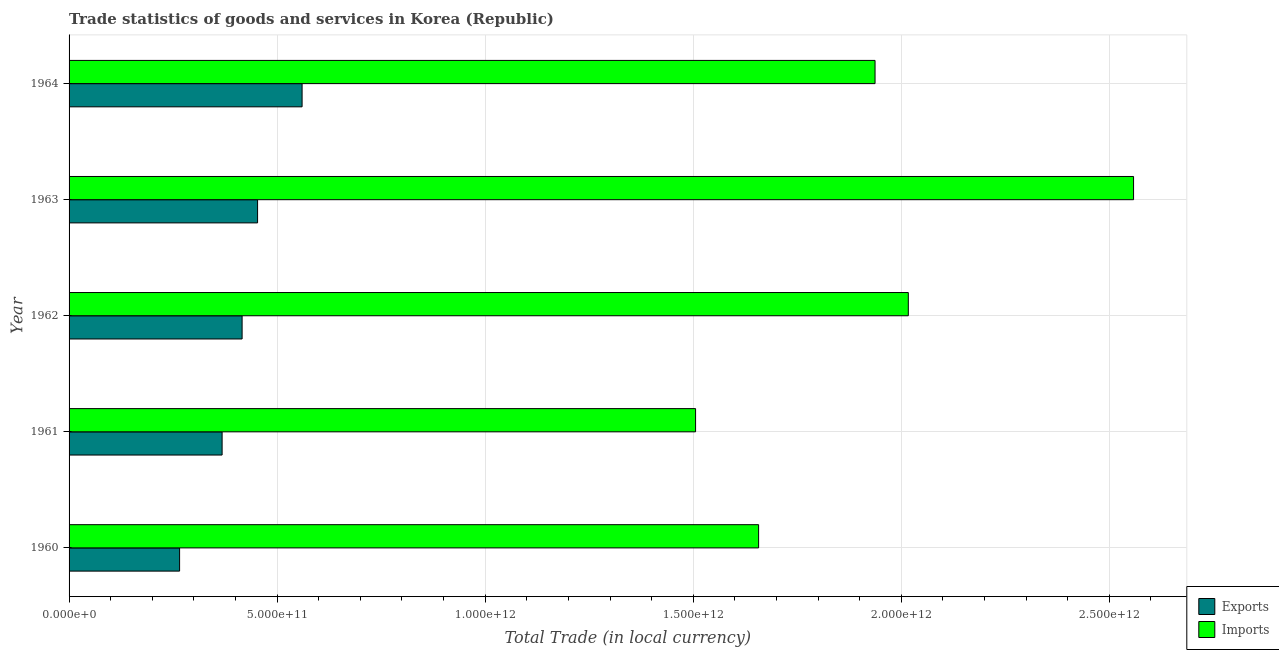How many different coloured bars are there?
Your answer should be compact. 2. How many groups of bars are there?
Keep it short and to the point. 5. How many bars are there on the 2nd tick from the bottom?
Offer a terse response. 2. What is the label of the 1st group of bars from the top?
Keep it short and to the point. 1964. In how many cases, is the number of bars for a given year not equal to the number of legend labels?
Provide a succinct answer. 0. What is the imports of goods and services in 1962?
Your answer should be very brief. 2.02e+12. Across all years, what is the maximum export of goods and services?
Your answer should be very brief. 5.60e+11. Across all years, what is the minimum imports of goods and services?
Ensure brevity in your answer.  1.51e+12. In which year was the export of goods and services maximum?
Give a very brief answer. 1964. In which year was the export of goods and services minimum?
Offer a very short reply. 1960. What is the total imports of goods and services in the graph?
Provide a succinct answer. 9.68e+12. What is the difference between the imports of goods and services in 1960 and that in 1964?
Make the answer very short. -2.80e+11. What is the difference between the imports of goods and services in 1964 and the export of goods and services in 1962?
Make the answer very short. 1.52e+12. What is the average export of goods and services per year?
Offer a very short reply. 4.12e+11. In the year 1963, what is the difference between the imports of goods and services and export of goods and services?
Offer a very short reply. 2.11e+12. What is the ratio of the imports of goods and services in 1960 to that in 1964?
Offer a very short reply. 0.86. What is the difference between the highest and the second highest export of goods and services?
Offer a very short reply. 1.07e+11. What is the difference between the highest and the lowest imports of goods and services?
Offer a very short reply. 1.05e+12. In how many years, is the export of goods and services greater than the average export of goods and services taken over all years?
Your response must be concise. 3. What does the 1st bar from the top in 1963 represents?
Offer a terse response. Imports. What does the 2nd bar from the bottom in 1961 represents?
Offer a very short reply. Imports. How many bars are there?
Make the answer very short. 10. Are all the bars in the graph horizontal?
Your answer should be very brief. Yes. What is the difference between two consecutive major ticks on the X-axis?
Make the answer very short. 5.00e+11. Does the graph contain any zero values?
Keep it short and to the point. No. Does the graph contain grids?
Make the answer very short. Yes. Where does the legend appear in the graph?
Offer a terse response. Bottom right. What is the title of the graph?
Offer a very short reply. Trade statistics of goods and services in Korea (Republic). Does "Passenger Transport Items" appear as one of the legend labels in the graph?
Offer a very short reply. No. What is the label or title of the X-axis?
Your answer should be compact. Total Trade (in local currency). What is the label or title of the Y-axis?
Give a very brief answer. Year. What is the Total Trade (in local currency) of Exports in 1960?
Make the answer very short. 2.66e+11. What is the Total Trade (in local currency) in Imports in 1960?
Offer a very short reply. 1.66e+12. What is the Total Trade (in local currency) in Exports in 1961?
Provide a short and direct response. 3.68e+11. What is the Total Trade (in local currency) in Imports in 1961?
Provide a short and direct response. 1.51e+12. What is the Total Trade (in local currency) of Exports in 1962?
Your response must be concise. 4.16e+11. What is the Total Trade (in local currency) in Imports in 1962?
Provide a succinct answer. 2.02e+12. What is the Total Trade (in local currency) in Exports in 1963?
Give a very brief answer. 4.53e+11. What is the Total Trade (in local currency) of Imports in 1963?
Offer a terse response. 2.56e+12. What is the Total Trade (in local currency) of Exports in 1964?
Your response must be concise. 5.60e+11. What is the Total Trade (in local currency) of Imports in 1964?
Ensure brevity in your answer.  1.94e+12. Across all years, what is the maximum Total Trade (in local currency) of Exports?
Your answer should be compact. 5.60e+11. Across all years, what is the maximum Total Trade (in local currency) of Imports?
Offer a terse response. 2.56e+12. Across all years, what is the minimum Total Trade (in local currency) of Exports?
Your answer should be compact. 2.66e+11. Across all years, what is the minimum Total Trade (in local currency) in Imports?
Offer a terse response. 1.51e+12. What is the total Total Trade (in local currency) in Exports in the graph?
Offer a very short reply. 2.06e+12. What is the total Total Trade (in local currency) of Imports in the graph?
Offer a terse response. 9.68e+12. What is the difference between the Total Trade (in local currency) in Exports in 1960 and that in 1961?
Your answer should be compact. -1.02e+11. What is the difference between the Total Trade (in local currency) in Imports in 1960 and that in 1961?
Offer a very short reply. 1.51e+11. What is the difference between the Total Trade (in local currency) in Exports in 1960 and that in 1962?
Your response must be concise. -1.50e+11. What is the difference between the Total Trade (in local currency) in Imports in 1960 and that in 1962?
Your response must be concise. -3.60e+11. What is the difference between the Total Trade (in local currency) of Exports in 1960 and that in 1963?
Ensure brevity in your answer.  -1.87e+11. What is the difference between the Total Trade (in local currency) in Imports in 1960 and that in 1963?
Provide a short and direct response. -9.01e+11. What is the difference between the Total Trade (in local currency) in Exports in 1960 and that in 1964?
Give a very brief answer. -2.94e+11. What is the difference between the Total Trade (in local currency) in Imports in 1960 and that in 1964?
Provide a succinct answer. -2.80e+11. What is the difference between the Total Trade (in local currency) of Exports in 1961 and that in 1962?
Ensure brevity in your answer.  -4.81e+1. What is the difference between the Total Trade (in local currency) of Imports in 1961 and that in 1962?
Keep it short and to the point. -5.11e+11. What is the difference between the Total Trade (in local currency) of Exports in 1961 and that in 1963?
Give a very brief answer. -8.52e+1. What is the difference between the Total Trade (in local currency) in Imports in 1961 and that in 1963?
Give a very brief answer. -1.05e+12. What is the difference between the Total Trade (in local currency) of Exports in 1961 and that in 1964?
Provide a short and direct response. -1.92e+11. What is the difference between the Total Trade (in local currency) of Imports in 1961 and that in 1964?
Provide a succinct answer. -4.31e+11. What is the difference between the Total Trade (in local currency) of Exports in 1962 and that in 1963?
Offer a very short reply. -3.72e+1. What is the difference between the Total Trade (in local currency) in Imports in 1962 and that in 1963?
Your answer should be compact. -5.41e+11. What is the difference between the Total Trade (in local currency) of Exports in 1962 and that in 1964?
Your answer should be compact. -1.44e+11. What is the difference between the Total Trade (in local currency) of Imports in 1962 and that in 1964?
Make the answer very short. 7.99e+1. What is the difference between the Total Trade (in local currency) of Exports in 1963 and that in 1964?
Provide a short and direct response. -1.07e+11. What is the difference between the Total Trade (in local currency) in Imports in 1963 and that in 1964?
Offer a very short reply. 6.21e+11. What is the difference between the Total Trade (in local currency) in Exports in 1960 and the Total Trade (in local currency) in Imports in 1961?
Your response must be concise. -1.24e+12. What is the difference between the Total Trade (in local currency) in Exports in 1960 and the Total Trade (in local currency) in Imports in 1962?
Ensure brevity in your answer.  -1.75e+12. What is the difference between the Total Trade (in local currency) in Exports in 1960 and the Total Trade (in local currency) in Imports in 1963?
Offer a terse response. -2.29e+12. What is the difference between the Total Trade (in local currency) of Exports in 1960 and the Total Trade (in local currency) of Imports in 1964?
Your response must be concise. -1.67e+12. What is the difference between the Total Trade (in local currency) in Exports in 1961 and the Total Trade (in local currency) in Imports in 1962?
Offer a terse response. -1.65e+12. What is the difference between the Total Trade (in local currency) in Exports in 1961 and the Total Trade (in local currency) in Imports in 1963?
Your response must be concise. -2.19e+12. What is the difference between the Total Trade (in local currency) of Exports in 1961 and the Total Trade (in local currency) of Imports in 1964?
Provide a succinct answer. -1.57e+12. What is the difference between the Total Trade (in local currency) of Exports in 1962 and the Total Trade (in local currency) of Imports in 1963?
Your response must be concise. -2.14e+12. What is the difference between the Total Trade (in local currency) in Exports in 1962 and the Total Trade (in local currency) in Imports in 1964?
Keep it short and to the point. -1.52e+12. What is the difference between the Total Trade (in local currency) of Exports in 1963 and the Total Trade (in local currency) of Imports in 1964?
Provide a succinct answer. -1.48e+12. What is the average Total Trade (in local currency) in Exports per year?
Your answer should be compact. 4.12e+11. What is the average Total Trade (in local currency) in Imports per year?
Offer a very short reply. 1.94e+12. In the year 1960, what is the difference between the Total Trade (in local currency) in Exports and Total Trade (in local currency) in Imports?
Your answer should be very brief. -1.39e+12. In the year 1961, what is the difference between the Total Trade (in local currency) of Exports and Total Trade (in local currency) of Imports?
Ensure brevity in your answer.  -1.14e+12. In the year 1962, what is the difference between the Total Trade (in local currency) of Exports and Total Trade (in local currency) of Imports?
Your answer should be very brief. -1.60e+12. In the year 1963, what is the difference between the Total Trade (in local currency) of Exports and Total Trade (in local currency) of Imports?
Offer a terse response. -2.11e+12. In the year 1964, what is the difference between the Total Trade (in local currency) in Exports and Total Trade (in local currency) in Imports?
Offer a terse response. -1.38e+12. What is the ratio of the Total Trade (in local currency) in Exports in 1960 to that in 1961?
Ensure brevity in your answer.  0.72. What is the ratio of the Total Trade (in local currency) in Imports in 1960 to that in 1961?
Make the answer very short. 1.1. What is the ratio of the Total Trade (in local currency) in Exports in 1960 to that in 1962?
Keep it short and to the point. 0.64. What is the ratio of the Total Trade (in local currency) of Imports in 1960 to that in 1962?
Make the answer very short. 0.82. What is the ratio of the Total Trade (in local currency) in Exports in 1960 to that in 1963?
Provide a short and direct response. 0.59. What is the ratio of the Total Trade (in local currency) in Imports in 1960 to that in 1963?
Ensure brevity in your answer.  0.65. What is the ratio of the Total Trade (in local currency) in Exports in 1960 to that in 1964?
Your response must be concise. 0.47. What is the ratio of the Total Trade (in local currency) in Imports in 1960 to that in 1964?
Your response must be concise. 0.86. What is the ratio of the Total Trade (in local currency) in Exports in 1961 to that in 1962?
Your answer should be very brief. 0.88. What is the ratio of the Total Trade (in local currency) of Imports in 1961 to that in 1962?
Offer a very short reply. 0.75. What is the ratio of the Total Trade (in local currency) of Exports in 1961 to that in 1963?
Keep it short and to the point. 0.81. What is the ratio of the Total Trade (in local currency) of Imports in 1961 to that in 1963?
Offer a very short reply. 0.59. What is the ratio of the Total Trade (in local currency) of Exports in 1961 to that in 1964?
Your answer should be very brief. 0.66. What is the ratio of the Total Trade (in local currency) in Imports in 1961 to that in 1964?
Make the answer very short. 0.78. What is the ratio of the Total Trade (in local currency) in Exports in 1962 to that in 1963?
Make the answer very short. 0.92. What is the ratio of the Total Trade (in local currency) in Imports in 1962 to that in 1963?
Offer a terse response. 0.79. What is the ratio of the Total Trade (in local currency) in Exports in 1962 to that in 1964?
Provide a short and direct response. 0.74. What is the ratio of the Total Trade (in local currency) in Imports in 1962 to that in 1964?
Make the answer very short. 1.04. What is the ratio of the Total Trade (in local currency) in Exports in 1963 to that in 1964?
Offer a very short reply. 0.81. What is the ratio of the Total Trade (in local currency) of Imports in 1963 to that in 1964?
Your answer should be very brief. 1.32. What is the difference between the highest and the second highest Total Trade (in local currency) in Exports?
Your answer should be compact. 1.07e+11. What is the difference between the highest and the second highest Total Trade (in local currency) of Imports?
Your response must be concise. 5.41e+11. What is the difference between the highest and the lowest Total Trade (in local currency) of Exports?
Offer a terse response. 2.94e+11. What is the difference between the highest and the lowest Total Trade (in local currency) of Imports?
Your response must be concise. 1.05e+12. 